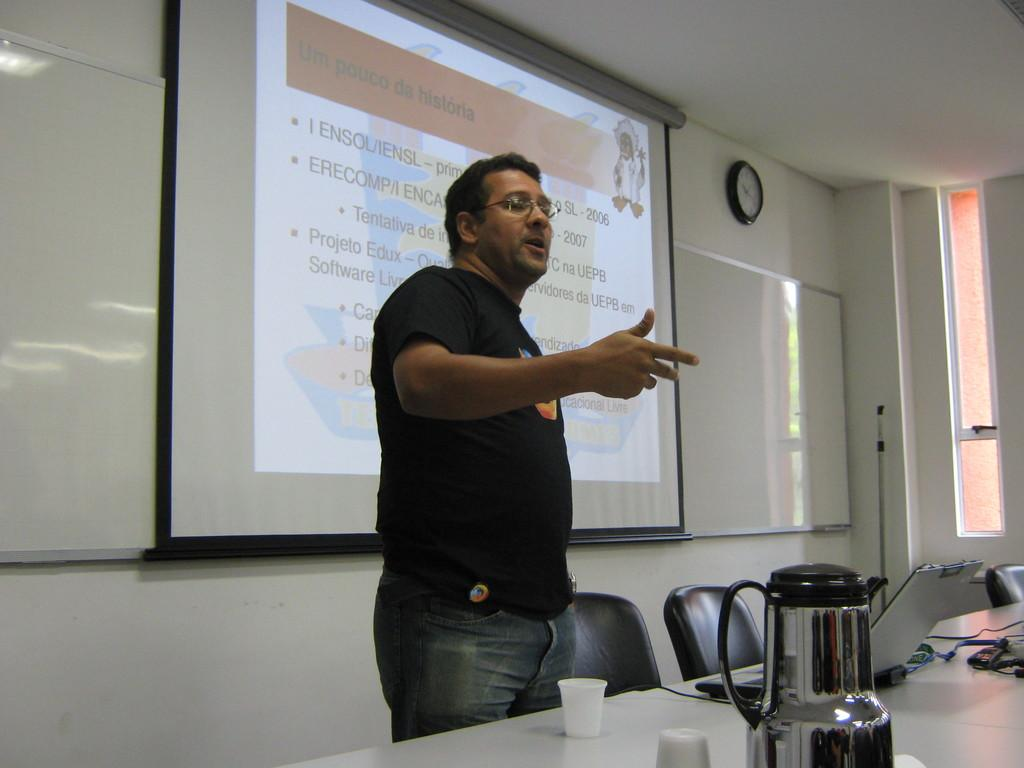<image>
Render a clear and concise summary of the photo. the word 2006 that is on a presentation 